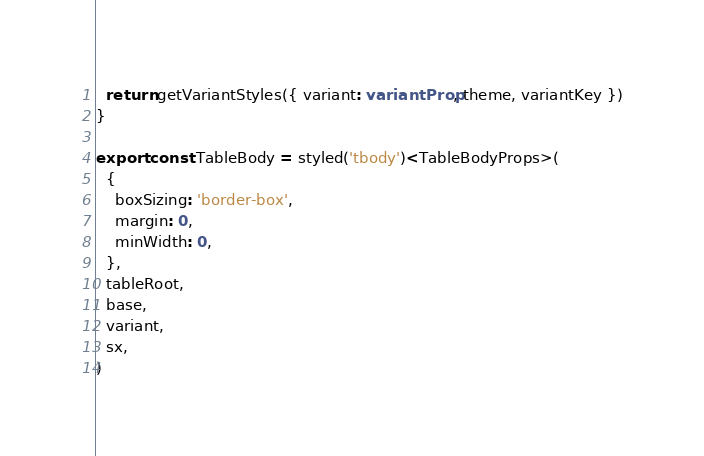Convert code to text. <code><loc_0><loc_0><loc_500><loc_500><_TypeScript_>  return getVariantStyles({ variant: variantProp, theme, variantKey })
}

export const TableBody = styled('tbody')<TableBodyProps>(
  {
    boxSizing: 'border-box',
    margin: 0,
    minWidth: 0,
  },
  tableRoot,
  base,
  variant,
  sx,
)
</code> 